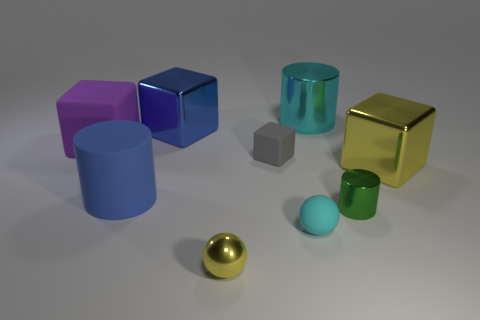How do the textures of the objects in the image compare? The textures vary among the objects. The cylinders have a smooth, reflective surface indicative of a polished metal finish. The cubes appear to have a slightly matte plastic texture, and the small rubber ball has an even duller, non-reflective surface suggesting it is made of rubber or another matte material. 